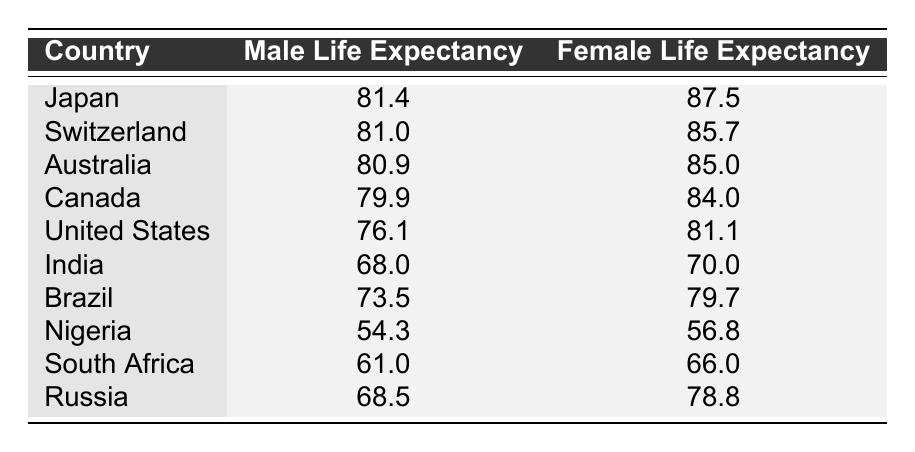What is the male life expectancy in Japan? According to the table, the male life expectancy for Japan is stated directly as 81.4 years.
Answer: 81.4 Which country has the highest female life expectancy? The table shows that Japan has the highest female life expectancy at 87.5 years, making it the highest among all listed countries.
Answer: Japan What is the difference in life expectancy between males and females in Canada? The male life expectancy in Canada is 79.9 years, and the female life expectancy is 84.0 years. To find the difference, we subtract: 84.0 - 79.9 = 4.1 years.
Answer: 4.1 Is the male life expectancy in the United States higher than in Brazil? The table shows the male life expectancy in the United States as 76.1 years and in Brazil as 73.5 years. Since 76.1 is greater than 73.5, the statement is true.
Answer: Yes What is the average male life expectancy across all countries in the table? To calculate the average male life expectancy, we first sum the male life expectancies: 81.4 + 81.0 + 80.9 + 79.9 + 76.1 + 68.0 + 73.5 + 54.3 + 61.0 + 68.5 = 766.6. There are 10 countries, so the average is 766.6 / 10 = 76.66 years.
Answer: 76.66 Which country has the lowest female life expectancy? In the table, Nigeria has the lowest female life expectancy at 56.8 years when comparing all the listed countries.
Answer: Nigeria What is the combined female life expectancy for Australia and Canada? The female life expectancy for Australia is 85.0 years and for Canada is 84.0 years. Adding these two values gives us 85.0 + 84.0 = 169.0 years.
Answer: 169.0 Is it true that male life expectancy in Russia is greater than that in Nigeria? The table indicates that the male life expectancy in Russia is 68.5 years, while in Nigeria it is 54.3 years. Therefore, the statement is true since 68.5 is greater than 54.3.
Answer: Yes What percentage of the male life expectancy in Japan is the female life expectancy? To find the percentage, we use the values: female life expectancy in Japan is 87.5 and male life expectancy is 81.4. The percentage is calculated as (87.5 / 81.4) * 100 = 107.5%.
Answer: 107.5% 